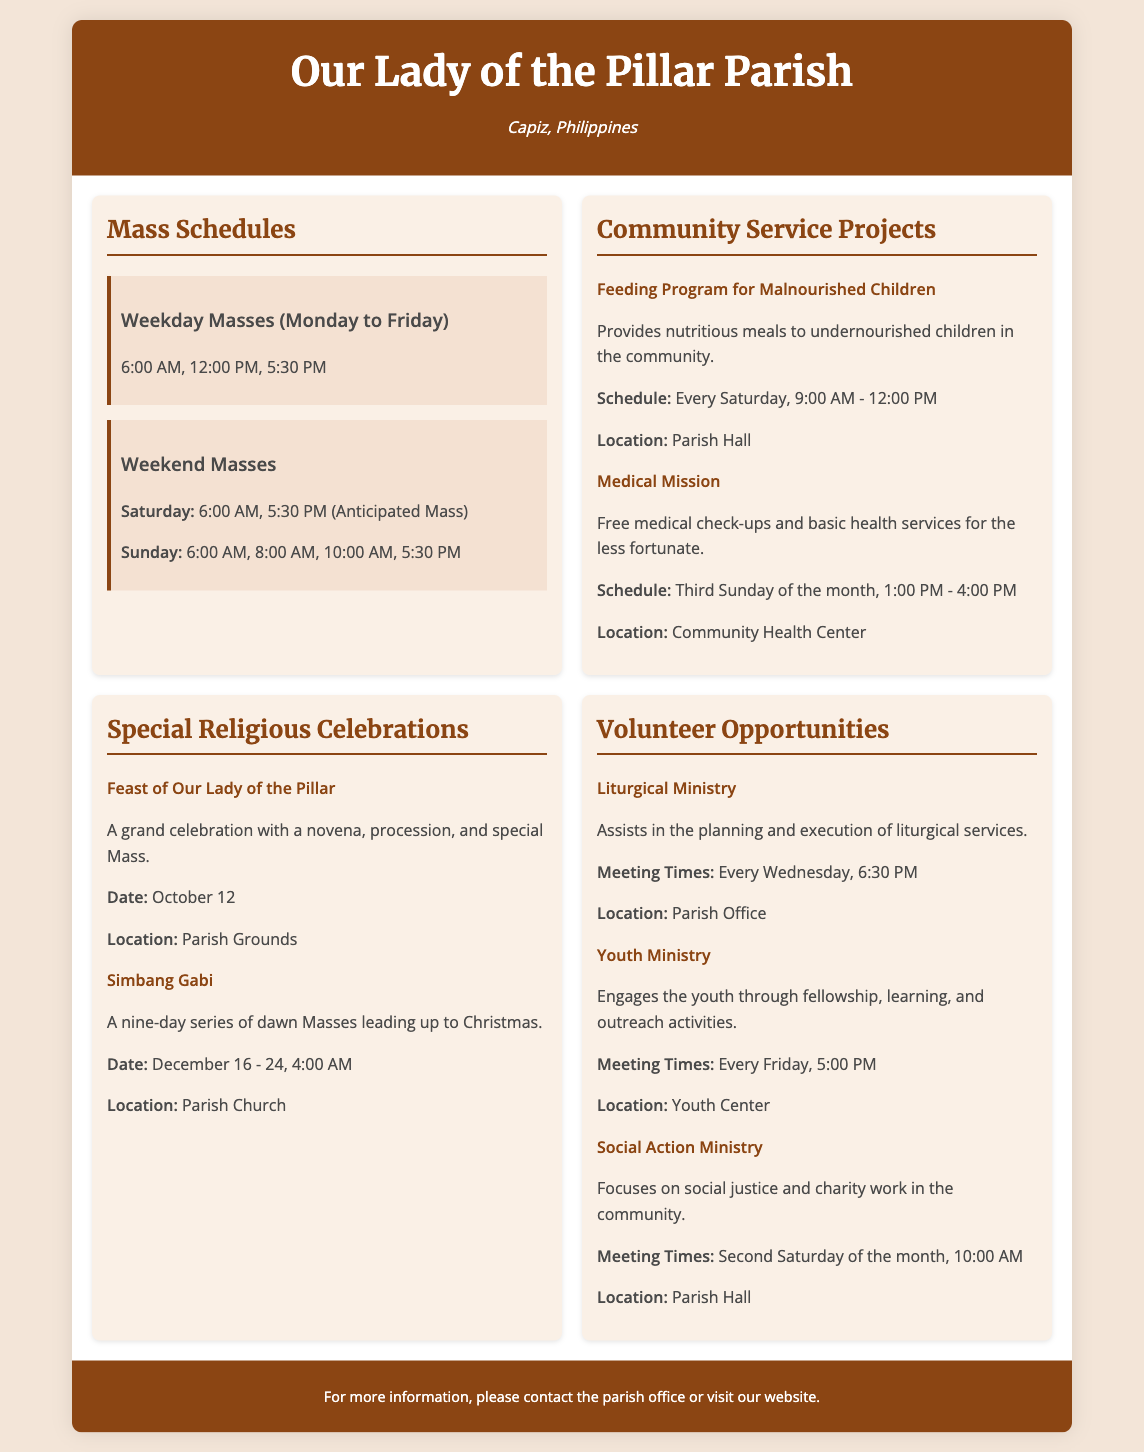What are the weekday Mass times? The weekday Mass times are listed in the document as 6:00 AM, 12:00 PM, and 5:30 PM.
Answer: 6:00 AM, 12:00 PM, 5:30 PM When is the Feeding Program for Malnourished Children held? The schedule for the Feeding Program for Malnourished Children is stated as every Saturday from 9:00 AM to 12:00 PM.
Answer: Every Saturday, 9:00 AM - 12:00 PM What special celebration takes place on October 12? The special celebration on October 12 is mentioned as the Feast of Our Lady of the Pillar.
Answer: Feast of Our Lady of the Pillar Which ministry meets every Wednesday? The ministry that meets every Wednesday is noted as the Liturgical Ministry.
Answer: Liturgical Ministry How many weekend Masses are there on Sunday? The document lists four weekend Masses on Sunday, which are 6:00 AM, 8:00 AM, 10:00 AM, and 5:30 PM.
Answer: Four What is the location for the Medical Mission? The Medical Mission's location is specified as the Community Health Center.
Answer: Community Health Center Which ministry focuses on social justice and charity work? The ministry that focuses on social justice and charity work is identified as the Social Action Ministry.
Answer: Social Action Ministry What time does Simbang Gabi start? The start time for Simbang Gabi is indicated as 4:00 AM.
Answer: 4:00 AM 